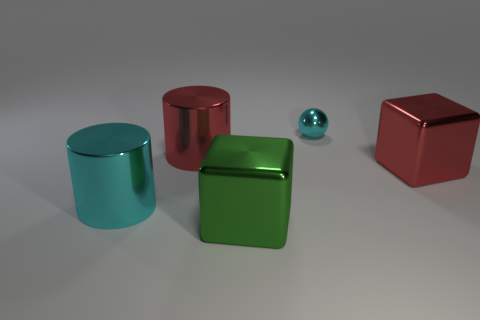Are there the same number of red cylinders right of the tiny metal object and big things that are behind the big red shiny block?
Provide a succinct answer. No. There is a big thing that is both left of the green cube and right of the big cyan thing; what is its color?
Give a very brief answer. Red. The big cyan thing that is made of the same material as the green thing is what shape?
Keep it short and to the point. Cylinder. There is a large cylinder that is in front of the big red metal object left of the large green block; what number of cyan balls are to the left of it?
Ensure brevity in your answer.  0. Does the cyan shiny object that is in front of the red cylinder have the same size as the green shiny thing in front of the small metallic thing?
Your answer should be compact. Yes. What is the material of the other large thing that is the same shape as the green thing?
Provide a short and direct response. Metal. What number of large objects are cylinders or red blocks?
Keep it short and to the point. 3. There is a thing that is both in front of the small cyan metal thing and right of the green thing; what is its material?
Your answer should be very brief. Metal. Do the metal sphere and the object that is to the left of the red metal cylinder have the same color?
Provide a short and direct response. Yes. There is another cylinder that is the same size as the cyan cylinder; what material is it?
Offer a very short reply. Metal. 